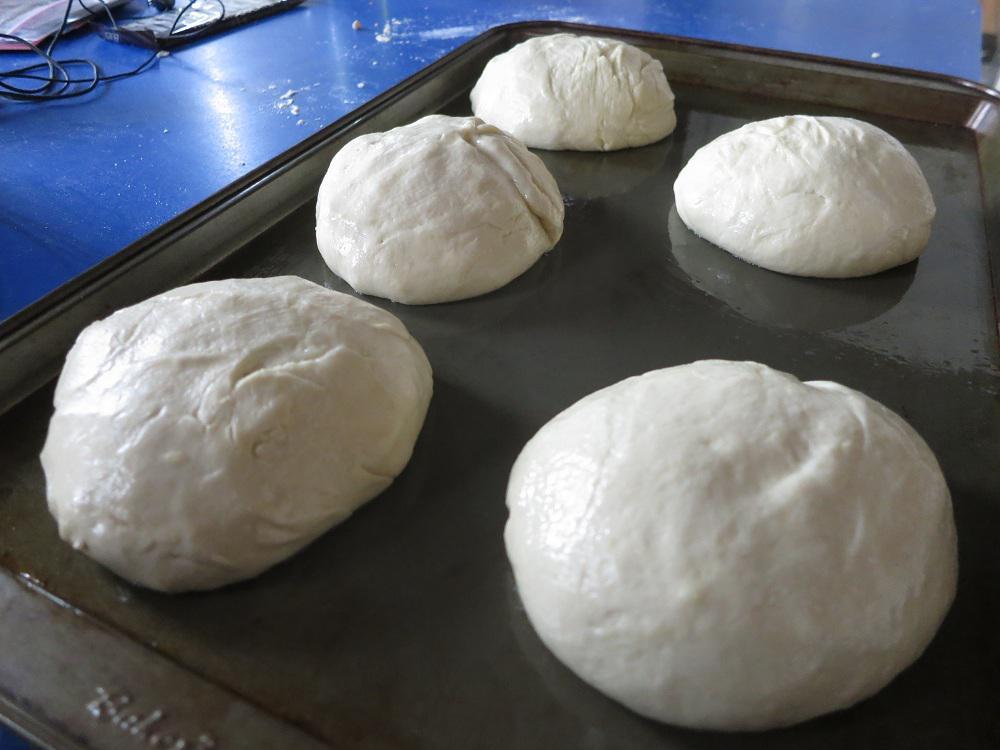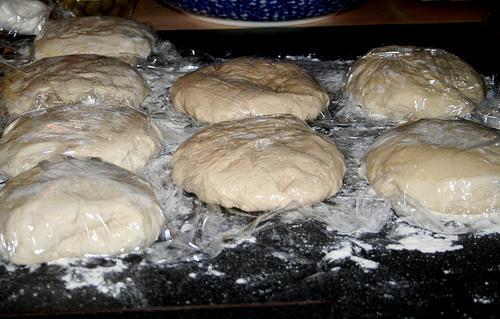The first image is the image on the left, the second image is the image on the right. Examine the images to the left and right. Is the description "A person is shaping dough by hand." accurate? Answer yes or no. No. The first image is the image on the left, the second image is the image on the right. For the images displayed, is the sentence "One and only one of the two images has hands in it." factually correct? Answer yes or no. No. 